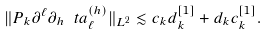<formula> <loc_0><loc_0><loc_500><loc_500>\| P _ { k } \partial ^ { \ell } \partial _ { h } \ t a _ { \ell } ^ { ( h ) } \| _ { L ^ { 2 } } \lesssim c _ { k } d _ { k } ^ { [ 1 ] } + d _ { k } c _ { k } ^ { [ 1 ] } .</formula> 